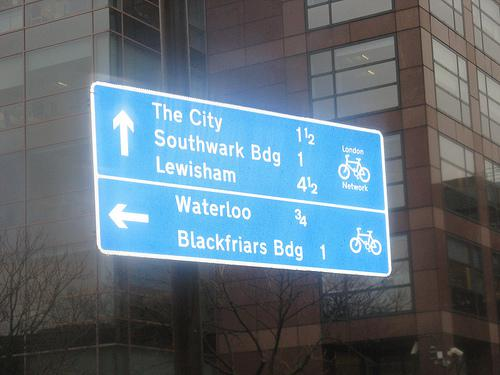Question: where is this scene?
Choices:
A. In the city.
B. The country.
C. The hotel.
D. The motel.
Answer with the letter. Answer: A Question: what color is the sign?
Choices:
A. Green.
B. Yellow.
C. Red.
D. White.
Answer with the letter. Answer: A Question: what are the poles made of?
Choices:
A. Wood.
B. Metal.
C. Cement.
D. Bamboo.
Answer with the letter. Answer: B Question: what has many windows?
Choices:
A. Building.
B. Bus.
C. Train.
D. Car.
Answer with the letter. Answer: A Question: when was the photo taken?
Choices:
A. Night time.
B. Dawn.
C. Dusk.
D. Daytime.
Answer with the letter. Answer: D Question: where was the photo taken?
Choices:
A. The yard.
B. The school.
C. On the street.
D. The house.
Answer with the letter. Answer: C 